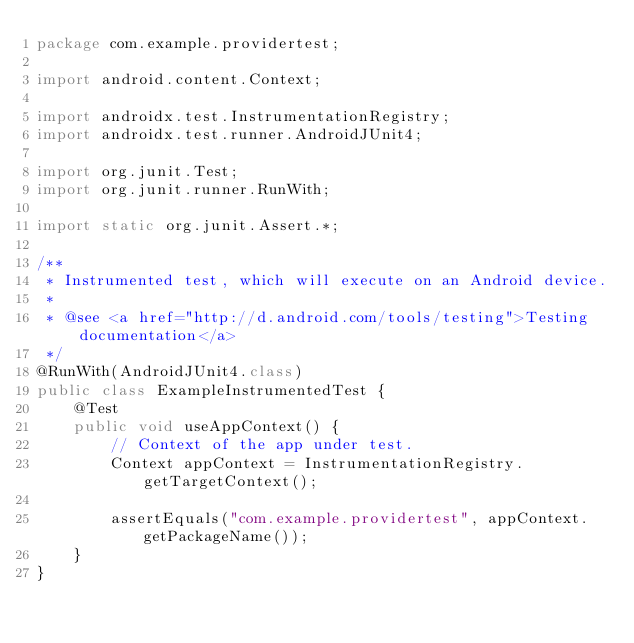Convert code to text. <code><loc_0><loc_0><loc_500><loc_500><_Java_>package com.example.providertest;

import android.content.Context;

import androidx.test.InstrumentationRegistry;
import androidx.test.runner.AndroidJUnit4;

import org.junit.Test;
import org.junit.runner.RunWith;

import static org.junit.Assert.*;

/**
 * Instrumented test, which will execute on an Android device.
 *
 * @see <a href="http://d.android.com/tools/testing">Testing documentation</a>
 */
@RunWith(AndroidJUnit4.class)
public class ExampleInstrumentedTest {
    @Test
    public void useAppContext() {
        // Context of the app under test.
        Context appContext = InstrumentationRegistry.getTargetContext();

        assertEquals("com.example.providertest", appContext.getPackageName());
    }
}
</code> 